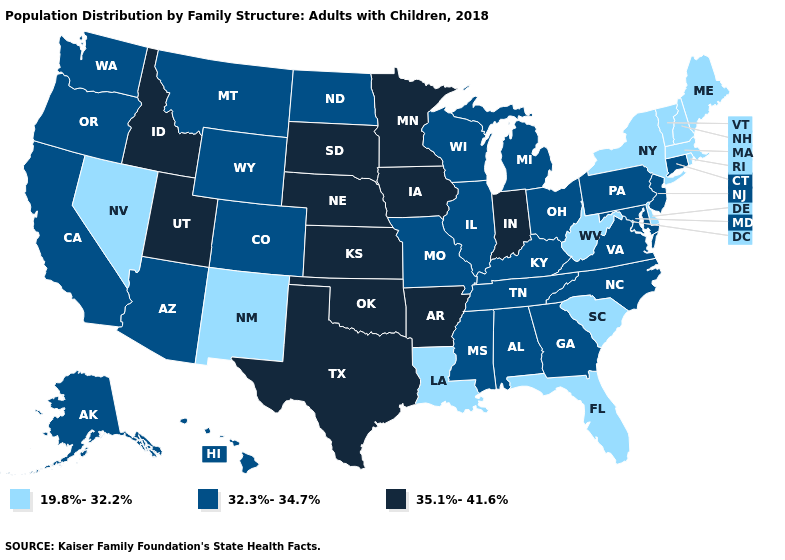Does New Mexico have a lower value than Delaware?
Quick response, please. No. What is the value of New Hampshire?
Concise answer only. 19.8%-32.2%. Name the states that have a value in the range 19.8%-32.2%?
Concise answer only. Delaware, Florida, Louisiana, Maine, Massachusetts, Nevada, New Hampshire, New Mexico, New York, Rhode Island, South Carolina, Vermont, West Virginia. Does New Mexico have the lowest value in the USA?
Be succinct. Yes. What is the value of Maryland?
Short answer required. 32.3%-34.7%. Which states have the highest value in the USA?
Quick response, please. Arkansas, Idaho, Indiana, Iowa, Kansas, Minnesota, Nebraska, Oklahoma, South Dakota, Texas, Utah. Does the first symbol in the legend represent the smallest category?
Keep it brief. Yes. Which states have the lowest value in the MidWest?
Quick response, please. Illinois, Michigan, Missouri, North Dakota, Ohio, Wisconsin. Name the states that have a value in the range 35.1%-41.6%?
Quick response, please. Arkansas, Idaho, Indiana, Iowa, Kansas, Minnesota, Nebraska, Oklahoma, South Dakota, Texas, Utah. What is the value of New York?
Give a very brief answer. 19.8%-32.2%. What is the value of South Dakota?
Concise answer only. 35.1%-41.6%. What is the lowest value in the MidWest?
Keep it brief. 32.3%-34.7%. How many symbols are there in the legend?
Give a very brief answer. 3. Among the states that border Kansas , which have the highest value?
Answer briefly. Nebraska, Oklahoma. How many symbols are there in the legend?
Give a very brief answer. 3. 